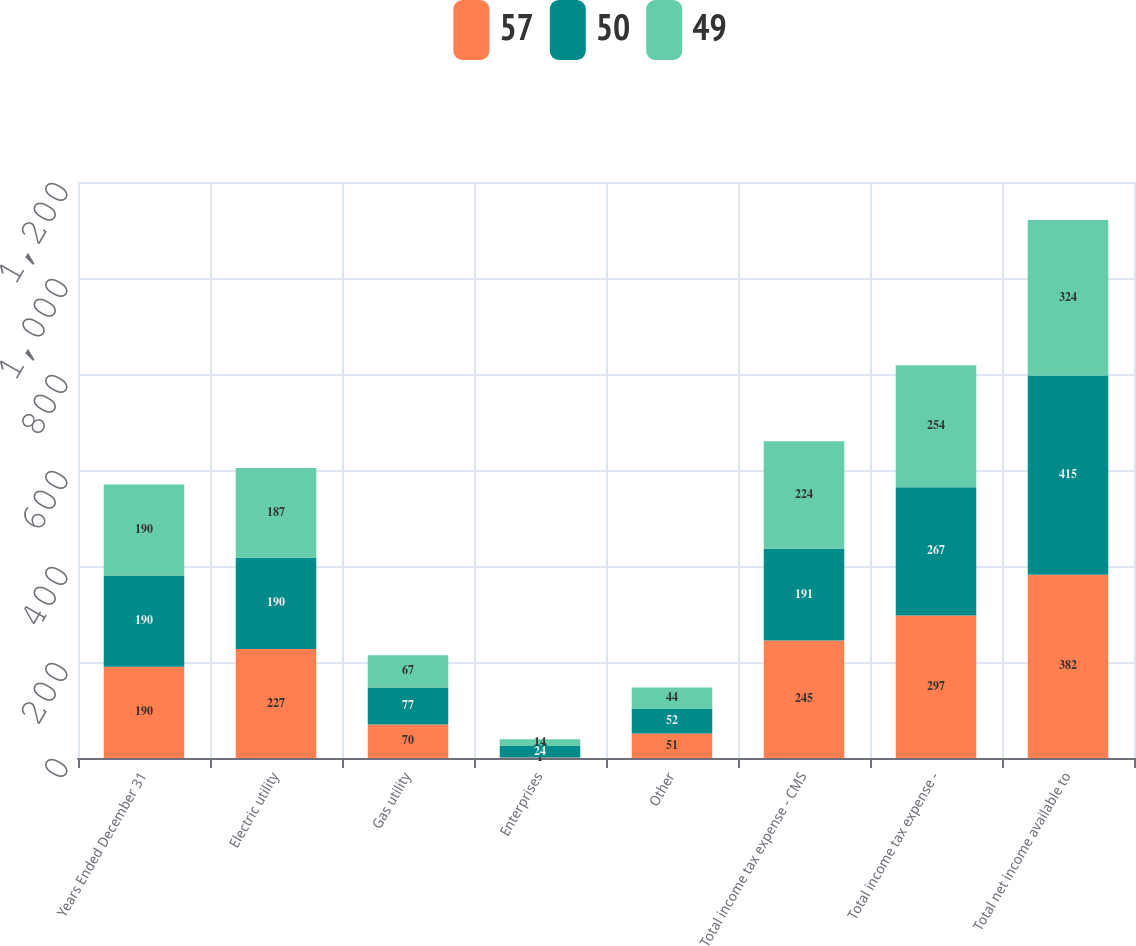Convert chart to OTSL. <chart><loc_0><loc_0><loc_500><loc_500><stacked_bar_chart><ecel><fcel>Years Ended December 31<fcel>Electric utility<fcel>Gas utility<fcel>Enterprises<fcel>Other<fcel>Total income tax expense - CMS<fcel>Total income tax expense -<fcel>Total net income available to<nl><fcel>57<fcel>190<fcel>227<fcel>70<fcel>1<fcel>51<fcel>245<fcel>297<fcel>382<nl><fcel>50<fcel>190<fcel>190<fcel>77<fcel>24<fcel>52<fcel>191<fcel>267<fcel>415<nl><fcel>49<fcel>190<fcel>187<fcel>67<fcel>14<fcel>44<fcel>224<fcel>254<fcel>324<nl></chart> 